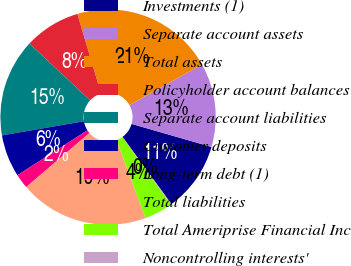Convert chart. <chart><loc_0><loc_0><loc_500><loc_500><pie_chart><fcel>Investments (1)<fcel>Separate account assets<fcel>Total assets<fcel>Policyholder account balances<fcel>Separate account liabilities<fcel>Customer deposits<fcel>Long-term debt (1)<fcel>Total liabilities<fcel>Total Ameriprise Financial Inc<fcel>Noncontrolling interests'<nl><fcel>10.51%<fcel>12.6%<fcel>21.47%<fcel>8.43%<fcel>14.68%<fcel>6.35%<fcel>2.19%<fcel>19.38%<fcel>4.27%<fcel>0.11%<nl></chart> 